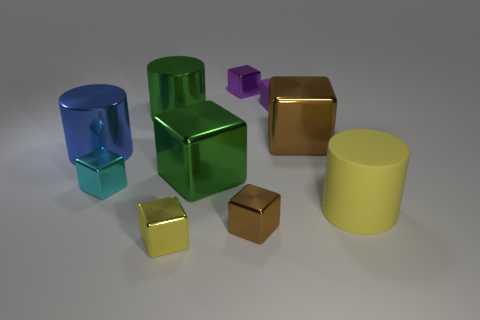Can you compare the sizes of the objects? The objects' sizes vary considerably, with the largest being the green cube and the smallest being the purple cube-shaped object. There is a noticeable gradient in size from the larger objects on the left, like the blue and green cubes and the yellow cylinder, to the smaller brown and gold cubes on the right. Do the different sizes suggest anything about their potential use or symbolic meaning? The variation in sizes might suggest a conceptual hierarchy or simply be a visual technique to create depth and interest in the composition. Symbolically, they could represent anything from building blocks in an abstract sense to scaled models of items, depending on the context in which they're used or presented. 